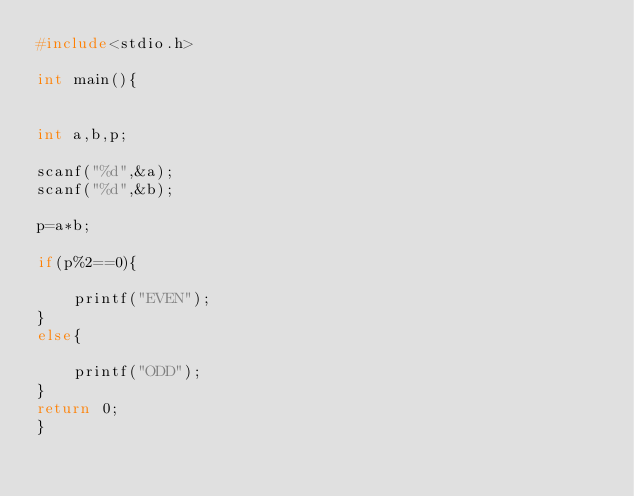Convert code to text. <code><loc_0><loc_0><loc_500><loc_500><_C_>#include<stdio.h>

int main(){


int a,b,p;

scanf("%d",&a);
scanf("%d",&b);

p=a*b;

if(p%2==0){

    printf("EVEN");
}
else{

    printf("ODD");
}
return 0;
}</code> 